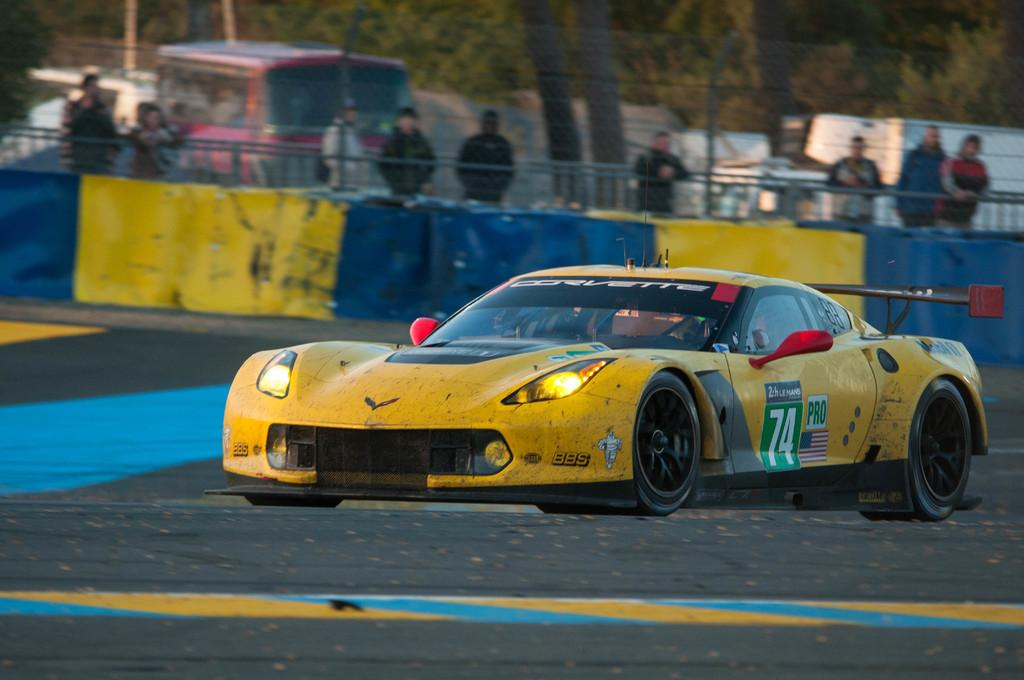What type of vehicle is the main subject of the image? There is a sports car in the image. What can be seen behind the sports car? There is a fence behind the sports car. Are there any people visible in the image? Yes, there are people standing behind the fence. What else can be seen in the background of the image? There is a vehicle and trees in the background of the image. How many babies are crawling on the sports car in the image? There are no babies present in the image; it features a sports car, a fence, people, and a background with a vehicle and trees. 